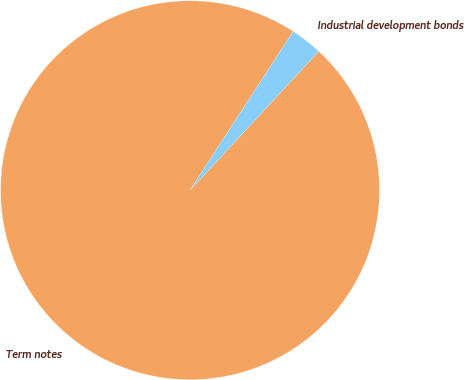<chart> <loc_0><loc_0><loc_500><loc_500><pie_chart><fcel>Term notes<fcel>Industrial development bonds<nl><fcel>97.28%<fcel>2.72%<nl></chart> 